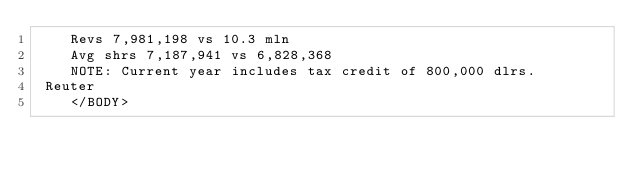<code> <loc_0><loc_0><loc_500><loc_500><_XML_>    Revs 7,981,198 vs 10.3 mln
    Avg shrs 7,187,941 vs 6,828,368
    NOTE: Current year includes tax credit of 800,000 dlrs.
 Reuter
    </BODY></code> 